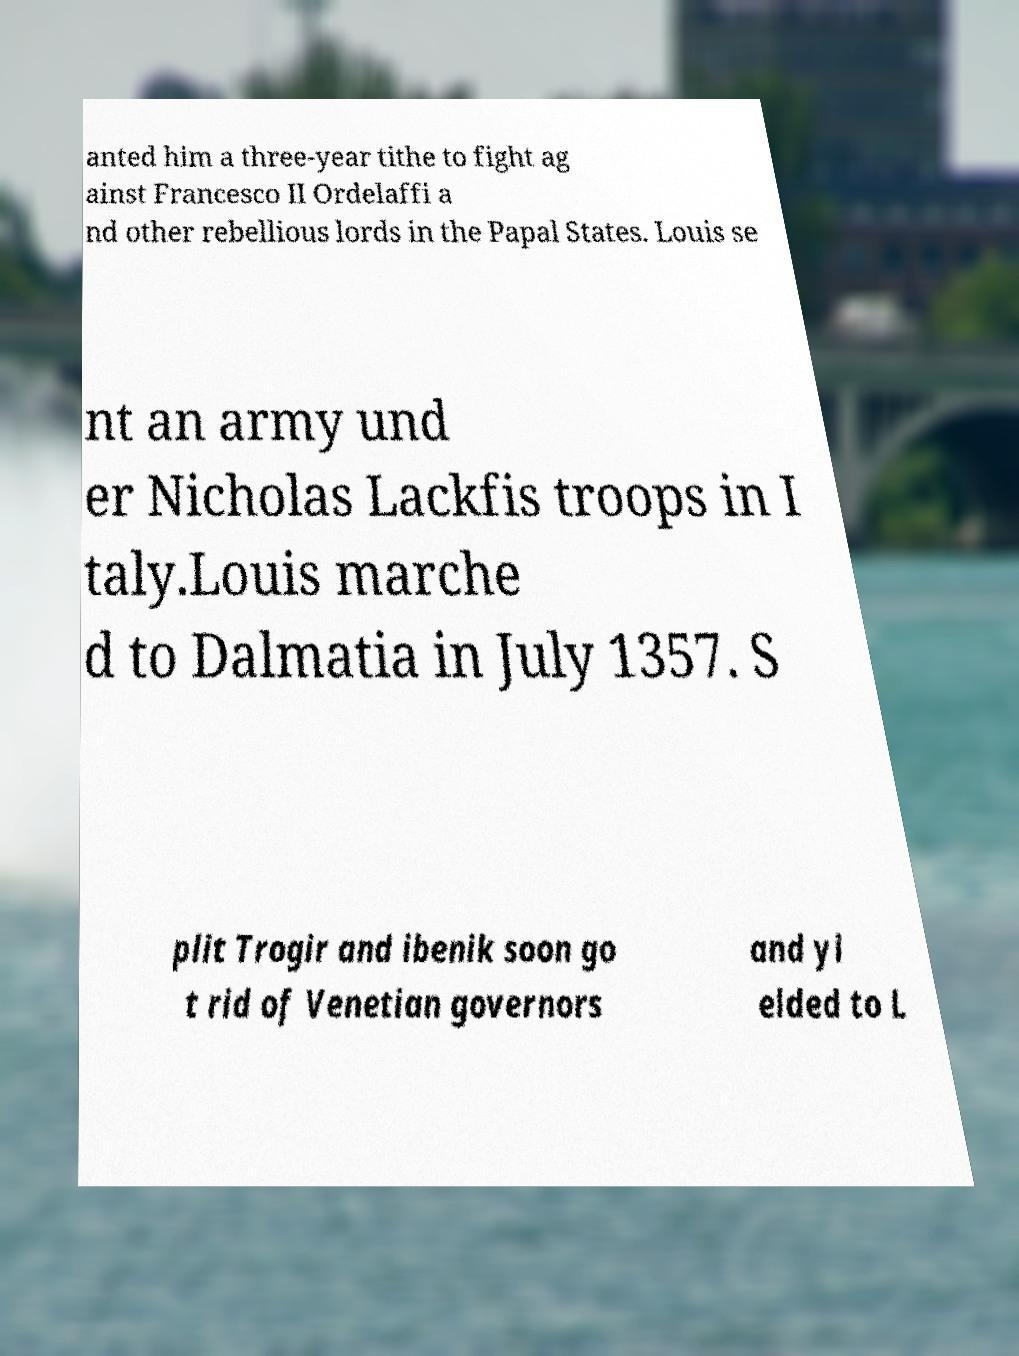Can you read and provide the text displayed in the image?This photo seems to have some interesting text. Can you extract and type it out for me? anted him a three-year tithe to fight ag ainst Francesco II Ordelaffi a nd other rebellious lords in the Papal States. Louis se nt an army und er Nicholas Lackfis troops in I taly.Louis marche d to Dalmatia in July 1357. S plit Trogir and ibenik soon go t rid of Venetian governors and yi elded to L 